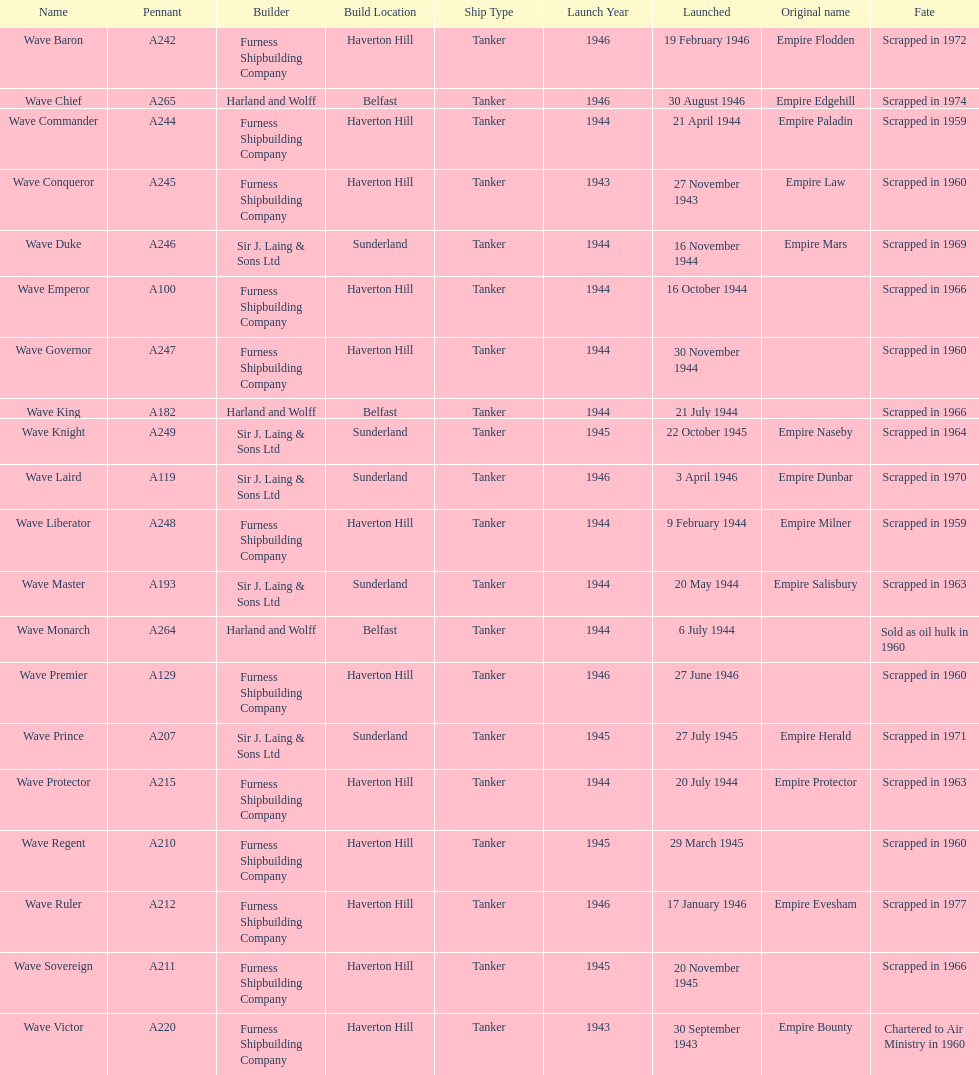I'm looking to parse the entire table for insights. Could you assist me with that? {'header': ['Name', 'Pennant', 'Builder', 'Build Location', 'Ship Type', 'Launch Year', 'Launched', 'Original name', 'Fate'], 'rows': [['Wave Baron', 'A242', 'Furness Shipbuilding Company', 'Haverton Hill', 'Tanker', '1946', '19 February 1946', 'Empire Flodden', 'Scrapped in 1972'], ['Wave Chief', 'A265', 'Harland and Wolff', 'Belfast', 'Tanker', '1946', '30 August 1946', 'Empire Edgehill', 'Scrapped in 1974'], ['Wave Commander', 'A244', 'Furness Shipbuilding Company', 'Haverton Hill', 'Tanker', '1944', '21 April 1944', 'Empire Paladin', 'Scrapped in 1959'], ['Wave Conqueror', 'A245', 'Furness Shipbuilding Company', 'Haverton Hill', 'Tanker', '1943', '27 November 1943', 'Empire Law', 'Scrapped in 1960'], ['Wave Duke', 'A246', 'Sir J. Laing & Sons Ltd', 'Sunderland', 'Tanker', '1944', '16 November 1944', 'Empire Mars', 'Scrapped in 1969'], ['Wave Emperor', 'A100', 'Furness Shipbuilding Company', 'Haverton Hill', 'Tanker', '1944', '16 October 1944', '', 'Scrapped in 1966'], ['Wave Governor', 'A247', 'Furness Shipbuilding Company', 'Haverton Hill', 'Tanker', '1944', '30 November 1944', '', 'Scrapped in 1960'], ['Wave King', 'A182', 'Harland and Wolff', 'Belfast', 'Tanker', '1944', '21 July 1944', '', 'Scrapped in 1966'], ['Wave Knight', 'A249', 'Sir J. Laing & Sons Ltd', 'Sunderland', 'Tanker', '1945', '22 October 1945', 'Empire Naseby', 'Scrapped in 1964'], ['Wave Laird', 'A119', 'Sir J. Laing & Sons Ltd', 'Sunderland', 'Tanker', '1946', '3 April 1946', 'Empire Dunbar', 'Scrapped in 1970'], ['Wave Liberator', 'A248', 'Furness Shipbuilding Company', 'Haverton Hill', 'Tanker', '1944', '9 February 1944', 'Empire Milner', 'Scrapped in 1959'], ['Wave Master', 'A193', 'Sir J. Laing & Sons Ltd', 'Sunderland', 'Tanker', '1944', '20 May 1944', 'Empire Salisbury', 'Scrapped in 1963'], ['Wave Monarch', 'A264', 'Harland and Wolff', 'Belfast', 'Tanker', '1944', '6 July 1944', '', 'Sold as oil hulk in 1960'], ['Wave Premier', 'A129', 'Furness Shipbuilding Company', 'Haverton Hill', 'Tanker', '1946', '27 June 1946', '', 'Scrapped in 1960'], ['Wave Prince', 'A207', 'Sir J. Laing & Sons Ltd', 'Sunderland', 'Tanker', '1945', '27 July 1945', 'Empire Herald', 'Scrapped in 1971'], ['Wave Protector', 'A215', 'Furness Shipbuilding Company', 'Haverton Hill', 'Tanker', '1944', '20 July 1944', 'Empire Protector', 'Scrapped in 1963'], ['Wave Regent', 'A210', 'Furness Shipbuilding Company', 'Haverton Hill', 'Tanker', '1945', '29 March 1945', '', 'Scrapped in 1960'], ['Wave Ruler', 'A212', 'Furness Shipbuilding Company', 'Haverton Hill', 'Tanker', '1946', '17 January 1946', 'Empire Evesham', 'Scrapped in 1977'], ['Wave Sovereign', 'A211', 'Furness Shipbuilding Company', 'Haverton Hill', 'Tanker', '1945', '20 November 1945', '', 'Scrapped in 1966'], ['Wave Victor', 'A220', 'Furness Shipbuilding Company', 'Haverton Hill', 'Tanker', '1943', '30 September 1943', 'Empire Bounty', 'Chartered to Air Ministry in 1960']]} What was the next wave class oiler after wave emperor? Wave Duke. 